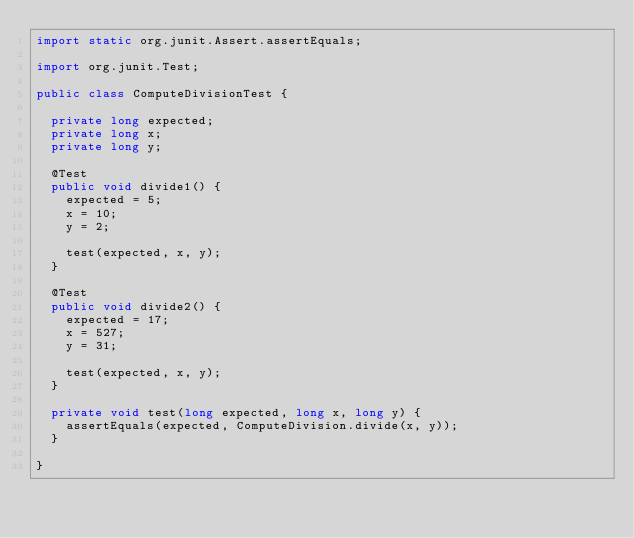Convert code to text. <code><loc_0><loc_0><loc_500><loc_500><_Java_>import static org.junit.Assert.assertEquals;

import org.junit.Test;

public class ComputeDivisionTest {

  private long expected;
  private long x;
  private long y;

  @Test
  public void divide1() {
    expected = 5;
    x = 10;
    y = 2;

    test(expected, x, y);
  }

  @Test
  public void divide2() {
    expected = 17;
    x = 527;
    y = 31;

    test(expected, x, y);
  }

  private void test(long expected, long x, long y) {
    assertEquals(expected, ComputeDivision.divide(x, y));
  }

}</code> 